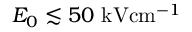Convert formula to latex. <formula><loc_0><loc_0><loc_500><loc_500>E _ { 0 } \lesssim 5 0 { k V c m ^ { - 1 } }</formula> 